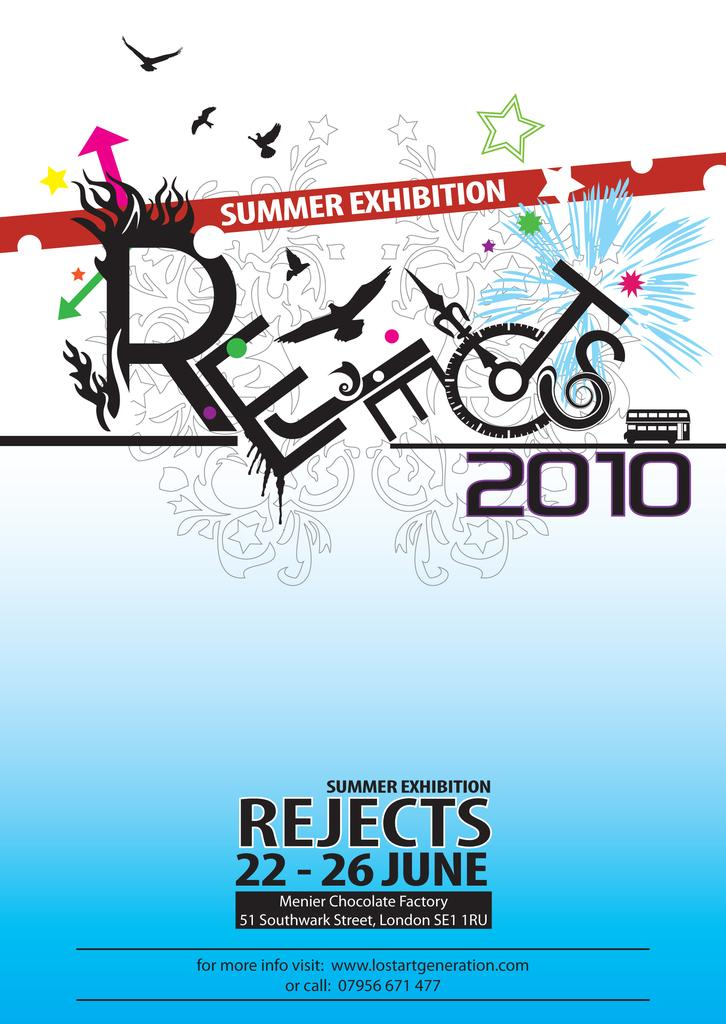<image>
Give a short and clear explanation of the subsequent image. a pamphlet with the word rejects on it 